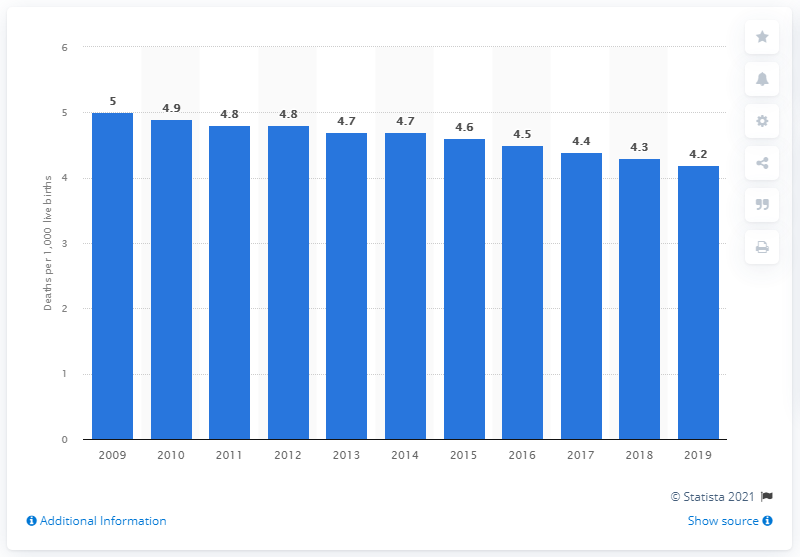Draw attention to some important aspects in this diagram. In 2019, the infant mortality rate in Canada was 4.2, indicating a relatively low number of infant deaths compared to other countries. 